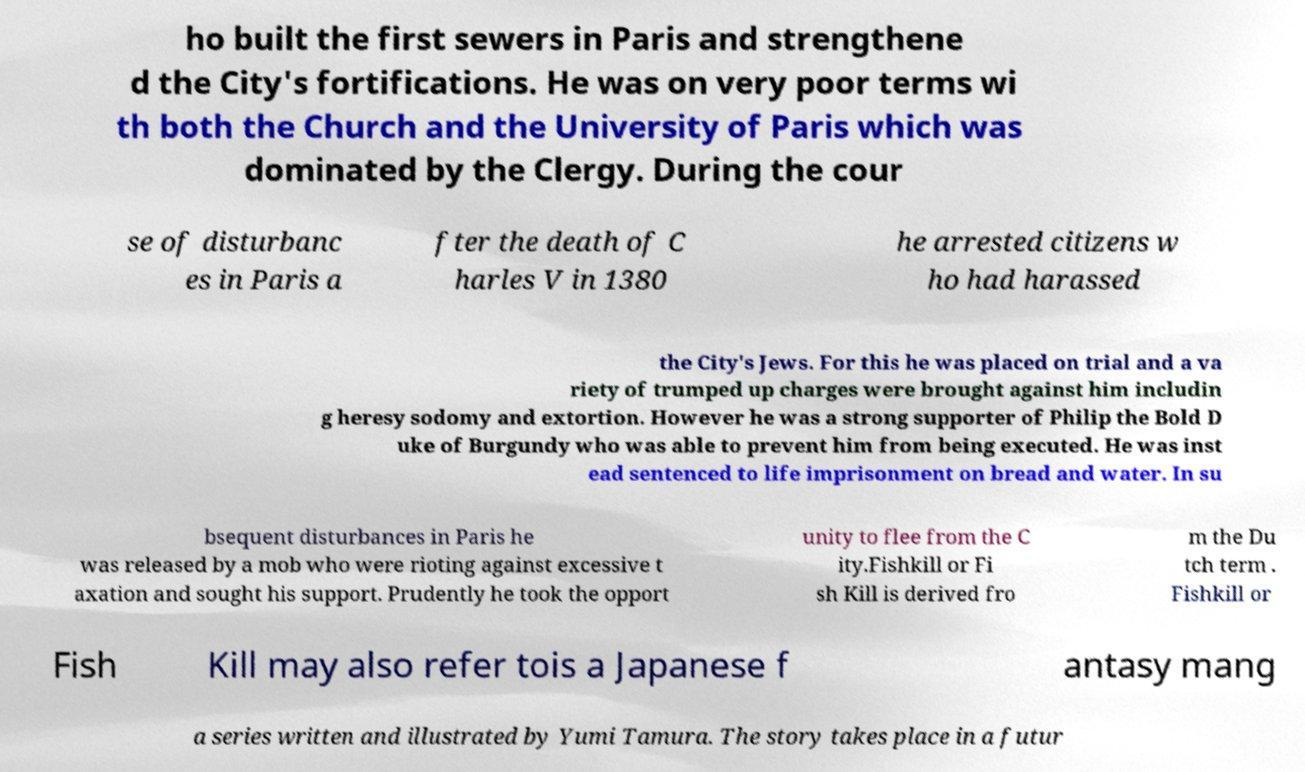Can you accurately transcribe the text from the provided image for me? ho built the first sewers in Paris and strengthene d the City's fortifications. He was on very poor terms wi th both the Church and the University of Paris which was dominated by the Clergy. During the cour se of disturbanc es in Paris a fter the death of C harles V in 1380 he arrested citizens w ho had harassed the City's Jews. For this he was placed on trial and a va riety of trumped up charges were brought against him includin g heresy sodomy and extortion. However he was a strong supporter of Philip the Bold D uke of Burgundy who was able to prevent him from being executed. He was inst ead sentenced to life imprisonment on bread and water. In su bsequent disturbances in Paris he was released by a mob who were rioting against excessive t axation and sought his support. Prudently he took the opport unity to flee from the C ity.Fishkill or Fi sh Kill is derived fro m the Du tch term . Fishkill or Fish Kill may also refer tois a Japanese f antasy mang a series written and illustrated by Yumi Tamura. The story takes place in a futur 